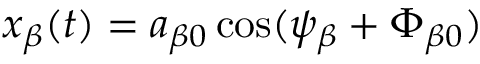<formula> <loc_0><loc_0><loc_500><loc_500>x _ { \beta } ( t ) = a _ { \beta 0 } \cos ( \psi _ { \beta } + \Phi _ { \beta 0 } )</formula> 